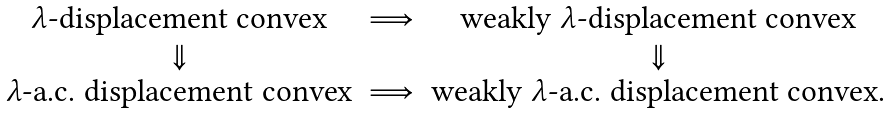Convert formula to latex. <formula><loc_0><loc_0><loc_500><loc_500>\begin{matrix} \text {$\lambda$-displacement convex} & \Longrightarrow & \text {weakly $\lambda$-displacement convex} \\ \Downarrow & & \Downarrow \\ \text {$\lambda$-a.c. displacement convex} & \Longrightarrow & \text {weakly $\lambda$-a.c. displacement convex.} \end{matrix}</formula> 